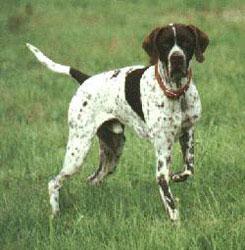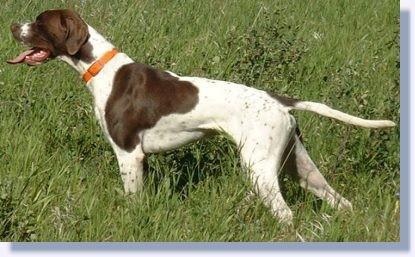The first image is the image on the left, the second image is the image on the right. Assess this claim about the two images: "In one of the images, there is a dog wearing an orange collar.". Correct or not? Answer yes or no. Yes. The first image is the image on the left, the second image is the image on the right. Assess this claim about the two images: "The dogs in both images are wearing collars.". Correct or not? Answer yes or no. Yes. 